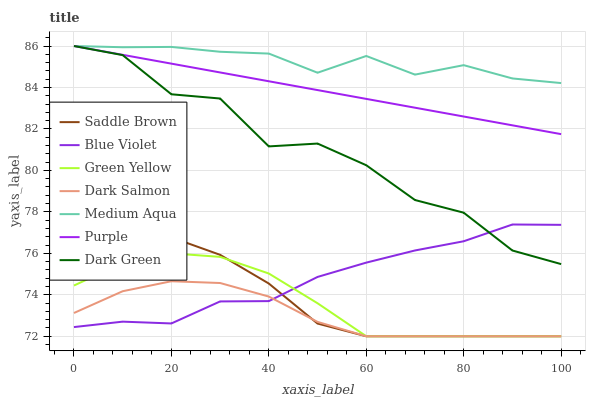Does Dark Salmon have the minimum area under the curve?
Answer yes or no. Yes. Does Medium Aqua have the maximum area under the curve?
Answer yes or no. Yes. Does Medium Aqua have the minimum area under the curve?
Answer yes or no. No. Does Dark Salmon have the maximum area under the curve?
Answer yes or no. No. Is Purple the smoothest?
Answer yes or no. Yes. Is Dark Green the roughest?
Answer yes or no. Yes. Is Dark Salmon the smoothest?
Answer yes or no. No. Is Dark Salmon the roughest?
Answer yes or no. No. Does Dark Salmon have the lowest value?
Answer yes or no. Yes. Does Medium Aqua have the lowest value?
Answer yes or no. No. Does Dark Green have the highest value?
Answer yes or no. Yes. Does Dark Salmon have the highest value?
Answer yes or no. No. Is Saddle Brown less than Medium Aqua?
Answer yes or no. Yes. Is Purple greater than Dark Salmon?
Answer yes or no. Yes. Does Dark Green intersect Blue Violet?
Answer yes or no. Yes. Is Dark Green less than Blue Violet?
Answer yes or no. No. Is Dark Green greater than Blue Violet?
Answer yes or no. No. Does Saddle Brown intersect Medium Aqua?
Answer yes or no. No. 